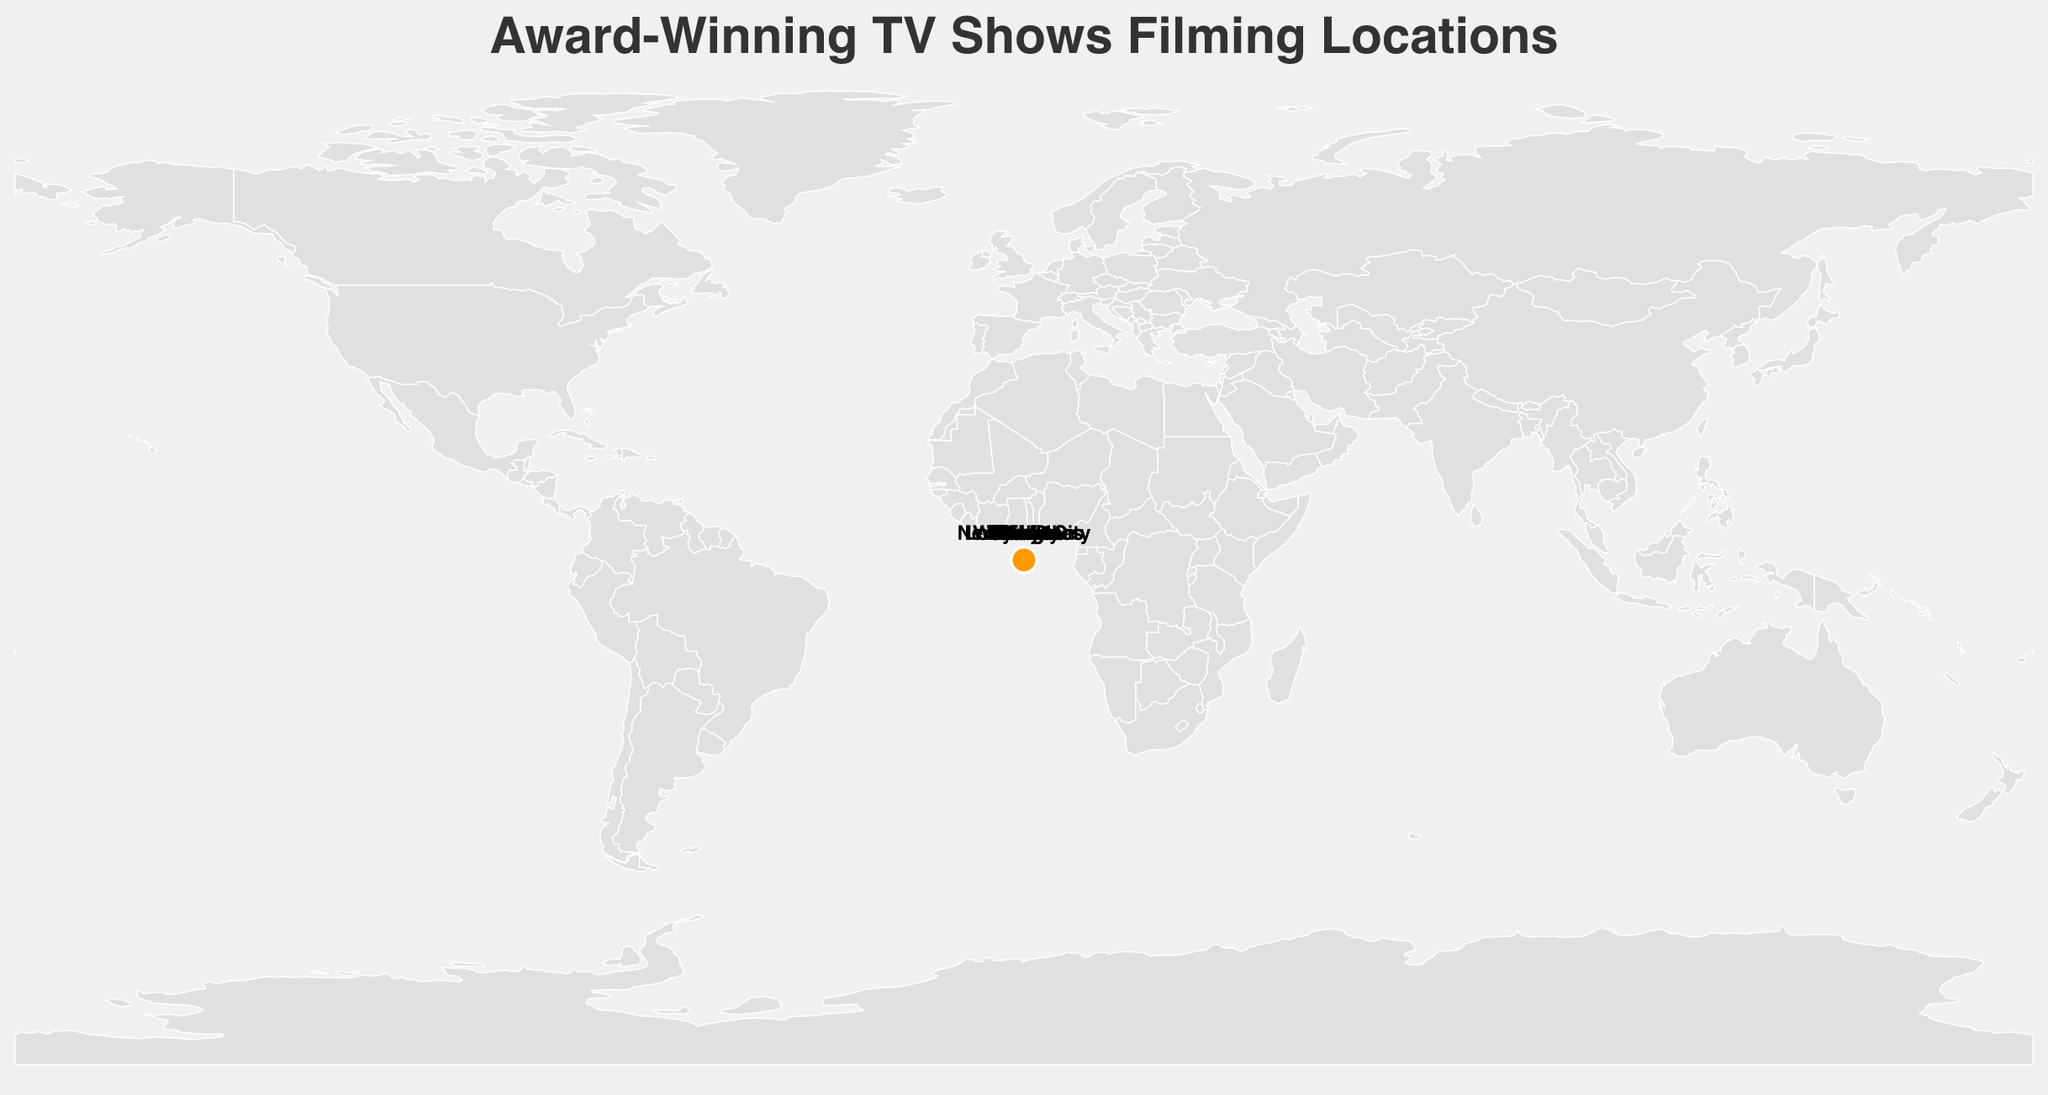what is the title of the plot? The title is usually displayed at the top of the plot. In this case, it should be the same as specified in the code.
Answer: Award-Winning TV Shows Filming Locations How many Emmy Awards did "Stranger Things" receive? Look for "Stranger Things" on the plot and note the number of its Emmy Awards.
Answer: 12 Which city has the highest number of Emmy Awards? Check the cities and their corresponding TV shows and count the Emmy Awards each city has.
Answer: Los Angeles (59 Emmy Awards for Game of Thrones) Which shows are filmed in cities located in the United States? Identify the cities labeled on the map in the United States and list the shows filmed there.
Answer: The Sopranos (New York City), Game of Thrones (Los Angeles), Stranger Things (Atlanta) What is the total number of Emmy Awards received by shows filmed in Europe? Identify the European cities on the map and sum their corresponding Emmy Awards.
Answer: 21 (The Crown in London) + 6 (Squid Game in Seoul) + 7 (The Lord of the Rings: The Rings of Power in Wellington) + 4 (Normal People in Dublin) = 38 Which city has a show that won the Grimme-Preis Award? Identify the show that won the Grimme-Preis Award and locate its corresponding city.
Answer: Berlin (Dark) Compare the number of Emmy Awards received by "The Crown" and "Schitt's Creek". Which one received more? Note the number of Emmy Awards received by "The Crown" and "Schitt's Creek" and compare.
Answer: The Crown (21) received more than Schitt's Creek (9) Which show filmed in Canada received multiple Emmy Awards? Identify the show filmed in Canada by looking at the city labeled Toronto and note its Emmy Awards.
Answer: Schitt's Creek (9 Emmy Awards) What is the combined number of awards (of any type) for shows filmed in Tokyo and Paris? Identify the awards received by the shows filmed in Tokyo and Paris and sum them up.
Answer: Terrace House (Tokyo) received Asia Rainbow TV Awards and Call My Agent! (Paris) received International Emmy Award, so combined, 2 awards (1 each) Which continents have filming locations for the shows displayed? Look at the geographic plot and identify the continents where the filming locations are marked.
Answer: North America, Europe, Asia, Oceania 